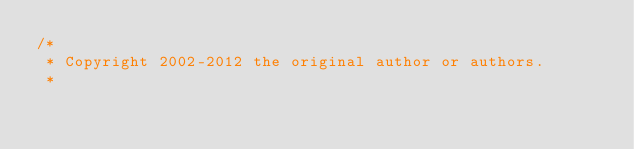Convert code to text. <code><loc_0><loc_0><loc_500><loc_500><_Java_>/*
 * Copyright 2002-2012 the original author or authors.
 *</code> 